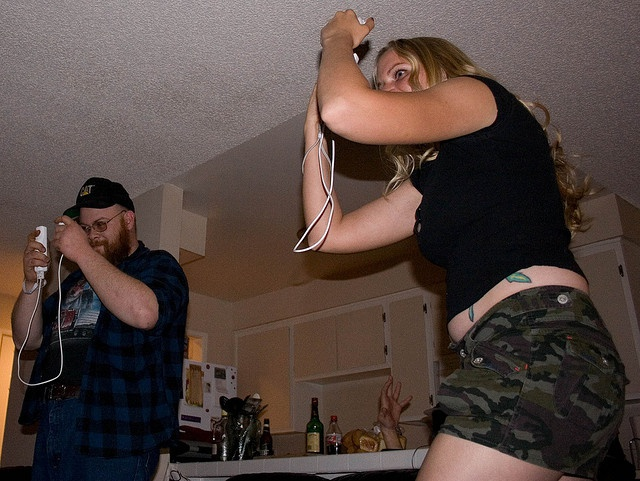Describe the objects in this image and their specific colors. I can see people in gray, black, brown, salmon, and maroon tones, people in gray, black, brown, and maroon tones, refrigerator in gray, black, and maroon tones, people in gray, maroon, black, and brown tones, and bottle in gray, black, and olive tones in this image. 